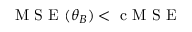<formula> <loc_0><loc_0><loc_500><loc_500>M S E ( \theta _ { B } ) < c M S E</formula> 